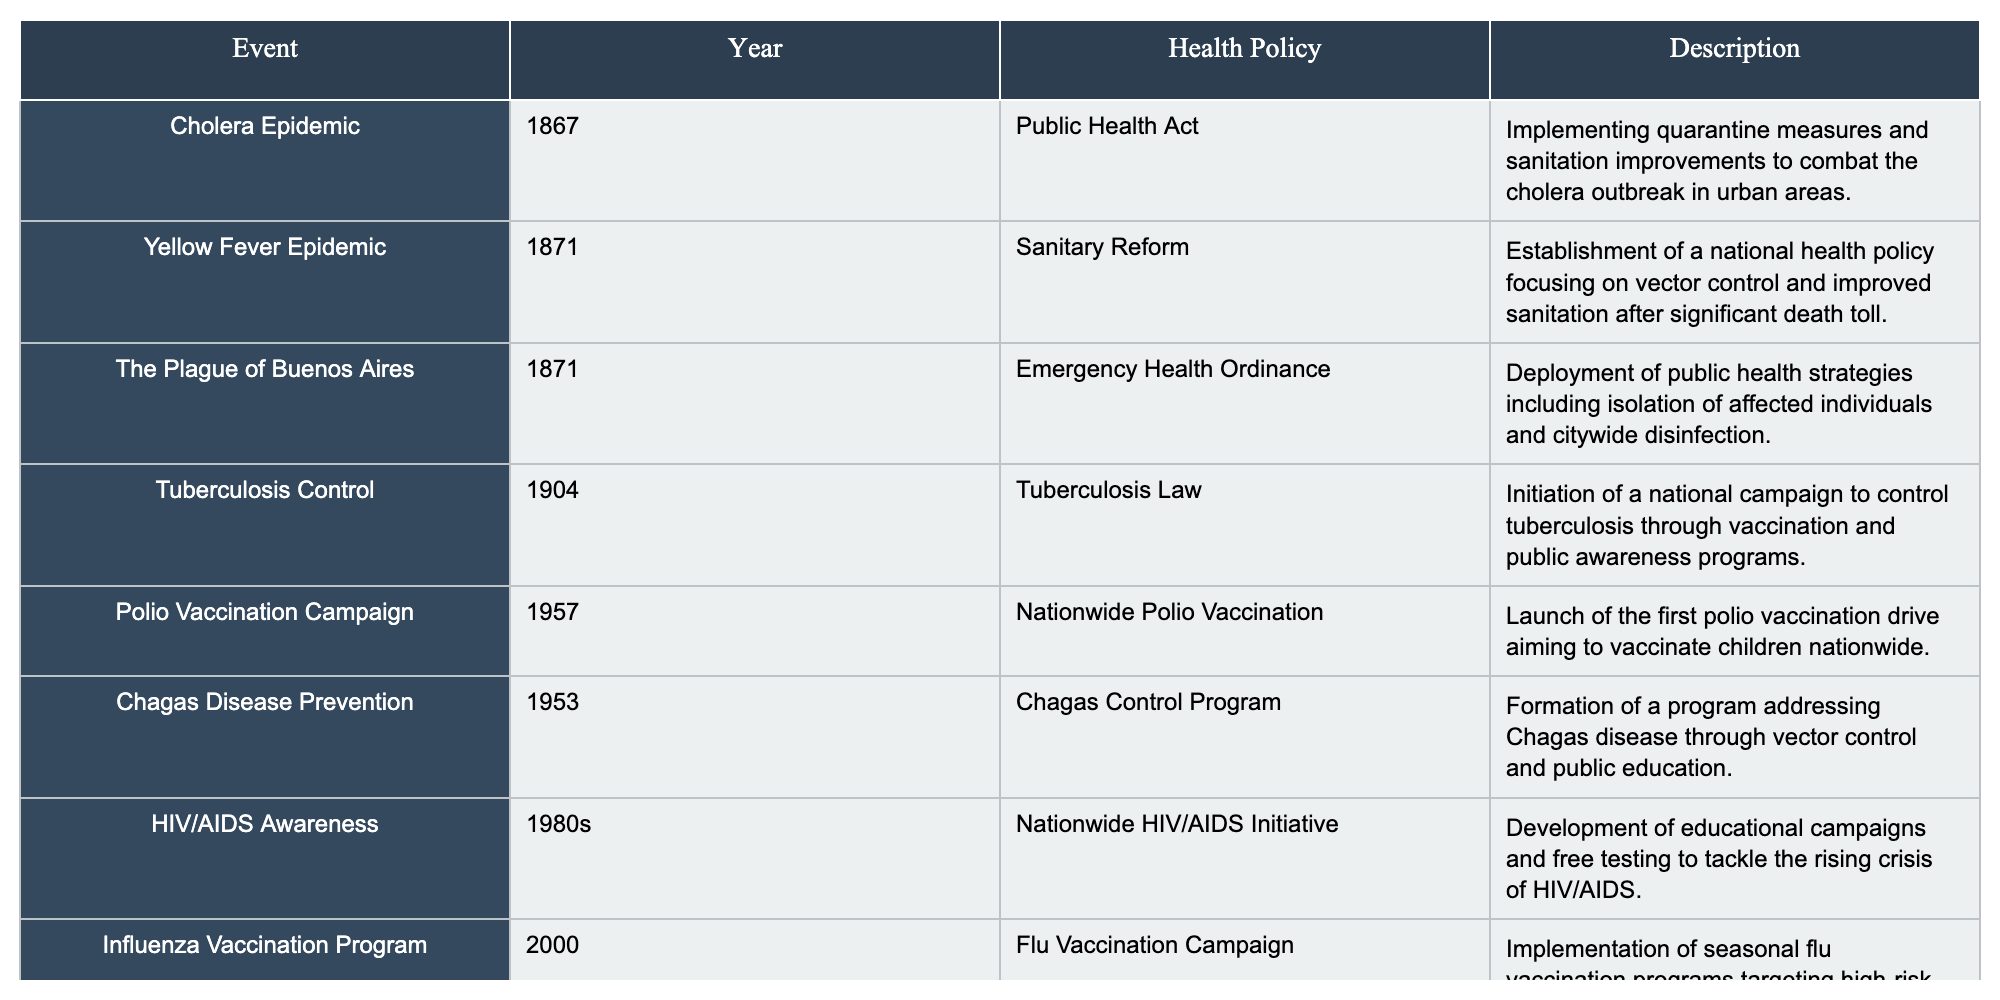What year did the cholera epidemic occur in Argentina? The table shows that the cholera epidemic occurred in the year 1867 as indicated in the "Year" column for the corresponding event.
Answer: 1867 What health policy was implemented in response to the Yellow Fever Epidemic? According to the table, the health policy implemented was the "Sanitary Reform" as listed under the "Health Policy" column for the Yellow Fever Epidemic in 1871.
Answer: Sanitary Reform How many public health policies are listed in the table? By counting the number of events in the table, we find there are a total of 8 public health policies associated with historical events in Argentina.
Answer: 8 Was there a public health initiative focused on tuberculosis? The table confirms that there was a public health initiative specifically called the "Tuberculosis Law" launched in 1904, indicating the focus was indeed on tuberculosis.
Answer: Yes In which decade did the HIV/AIDS Awareness initiative begin in Argentina? The table indicates that the Nationwide HIV/AIDS Initiative started in the 1980s, as reflected in the "Year" column.
Answer: 1980s Which health policy addressed Chagas disease, and in what year was it established? The table specifies that the "Chagas Control Program" was the health policy aimed at Chagas disease, and it was established in the year 1953.
Answer: Chagas Control Program, 1953 What is the difference in years between the cholera epidemic and the polio vaccination campaign? The cholera epidemic occurred in 1867 and the polio vaccination campaign in 1957. The difference in years is calculated as 1957 - 1867 = 90 years.
Answer: 90 years Which public health event occurred in the same year as the Yellow Fever Epidemic? The table shows that the "Plague of Buenos Aires" also occurred in 1871, which is the same year as the Yellow Fever Epidemic.
Answer: Plague of Buenos Aires Which health policy was the first to launch a nationwide campaign for vaccination? Based on the table, the first nationwide vaccination campaign was the "Polio Vaccination Campaign" initiated in 1957.
Answer: Polio Vaccination Campaign Was there an emergency measure taken during the Plague of Buenos Aires? The table lists the "Emergency Health Ordinance" as a measure taken during the Plague of Buenos Aires in 1871, which confirms that emergency measures were implemented.
Answer: Yes 